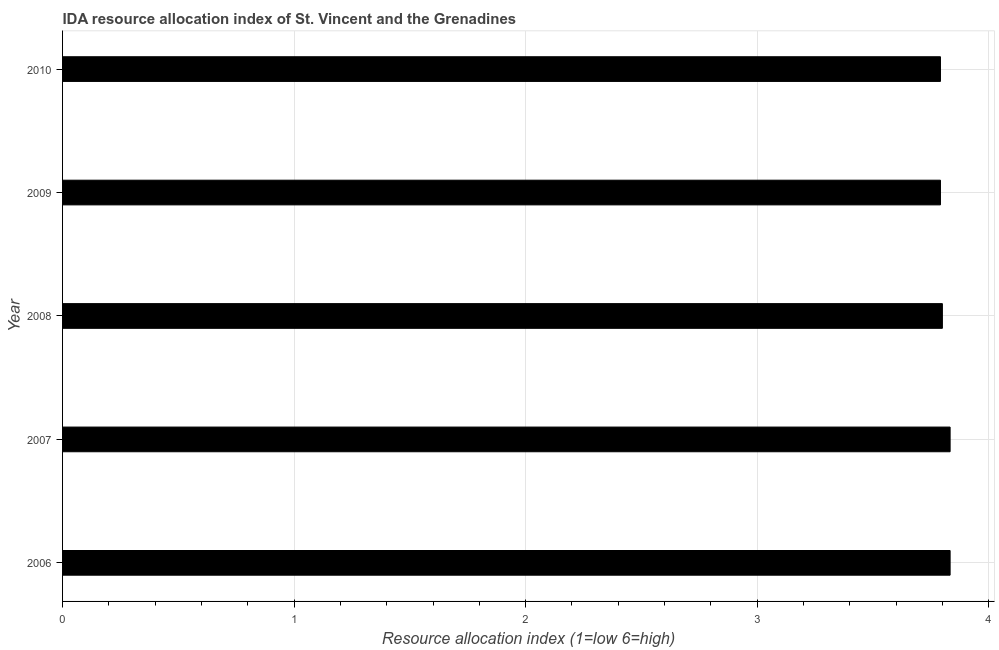What is the title of the graph?
Make the answer very short. IDA resource allocation index of St. Vincent and the Grenadines. What is the label or title of the X-axis?
Provide a succinct answer. Resource allocation index (1=low 6=high). What is the label or title of the Y-axis?
Your answer should be very brief. Year. What is the ida resource allocation index in 2008?
Provide a succinct answer. 3.8. Across all years, what is the maximum ida resource allocation index?
Your answer should be very brief. 3.83. Across all years, what is the minimum ida resource allocation index?
Your answer should be compact. 3.79. In which year was the ida resource allocation index maximum?
Your response must be concise. 2006. What is the sum of the ida resource allocation index?
Make the answer very short. 19.05. What is the average ida resource allocation index per year?
Offer a terse response. 3.81. What is the median ida resource allocation index?
Keep it short and to the point. 3.8. In how many years, is the ida resource allocation index greater than 3.2 ?
Offer a very short reply. 5. Do a majority of the years between 2006 and 2007 (inclusive) have ida resource allocation index greater than 2 ?
Provide a short and direct response. Yes. What is the ratio of the ida resource allocation index in 2007 to that in 2008?
Keep it short and to the point. 1.01. Is the ida resource allocation index in 2006 less than that in 2008?
Provide a short and direct response. No. Is the sum of the ida resource allocation index in 2008 and 2009 greater than the maximum ida resource allocation index across all years?
Ensure brevity in your answer.  Yes. What is the difference between the highest and the lowest ida resource allocation index?
Give a very brief answer. 0.04. In how many years, is the ida resource allocation index greater than the average ida resource allocation index taken over all years?
Your answer should be compact. 2. Are all the bars in the graph horizontal?
Your response must be concise. Yes. What is the difference between two consecutive major ticks on the X-axis?
Give a very brief answer. 1. Are the values on the major ticks of X-axis written in scientific E-notation?
Keep it short and to the point. No. What is the Resource allocation index (1=low 6=high) in 2006?
Your answer should be compact. 3.83. What is the Resource allocation index (1=low 6=high) in 2007?
Your answer should be compact. 3.83. What is the Resource allocation index (1=low 6=high) in 2008?
Offer a very short reply. 3.8. What is the Resource allocation index (1=low 6=high) in 2009?
Your answer should be compact. 3.79. What is the Resource allocation index (1=low 6=high) of 2010?
Your response must be concise. 3.79. What is the difference between the Resource allocation index (1=low 6=high) in 2006 and 2007?
Make the answer very short. 0. What is the difference between the Resource allocation index (1=low 6=high) in 2006 and 2008?
Offer a very short reply. 0.03. What is the difference between the Resource allocation index (1=low 6=high) in 2006 and 2009?
Your answer should be compact. 0.04. What is the difference between the Resource allocation index (1=low 6=high) in 2006 and 2010?
Your answer should be compact. 0.04. What is the difference between the Resource allocation index (1=low 6=high) in 2007 and 2008?
Give a very brief answer. 0.03. What is the difference between the Resource allocation index (1=low 6=high) in 2007 and 2009?
Make the answer very short. 0.04. What is the difference between the Resource allocation index (1=low 6=high) in 2007 and 2010?
Ensure brevity in your answer.  0.04. What is the difference between the Resource allocation index (1=low 6=high) in 2008 and 2009?
Give a very brief answer. 0.01. What is the difference between the Resource allocation index (1=low 6=high) in 2008 and 2010?
Keep it short and to the point. 0.01. What is the ratio of the Resource allocation index (1=low 6=high) in 2007 to that in 2008?
Make the answer very short. 1.01. What is the ratio of the Resource allocation index (1=low 6=high) in 2007 to that in 2009?
Give a very brief answer. 1.01. What is the ratio of the Resource allocation index (1=low 6=high) in 2007 to that in 2010?
Provide a short and direct response. 1.01. What is the ratio of the Resource allocation index (1=low 6=high) in 2008 to that in 2009?
Your answer should be compact. 1. What is the ratio of the Resource allocation index (1=low 6=high) in 2009 to that in 2010?
Your answer should be compact. 1. 